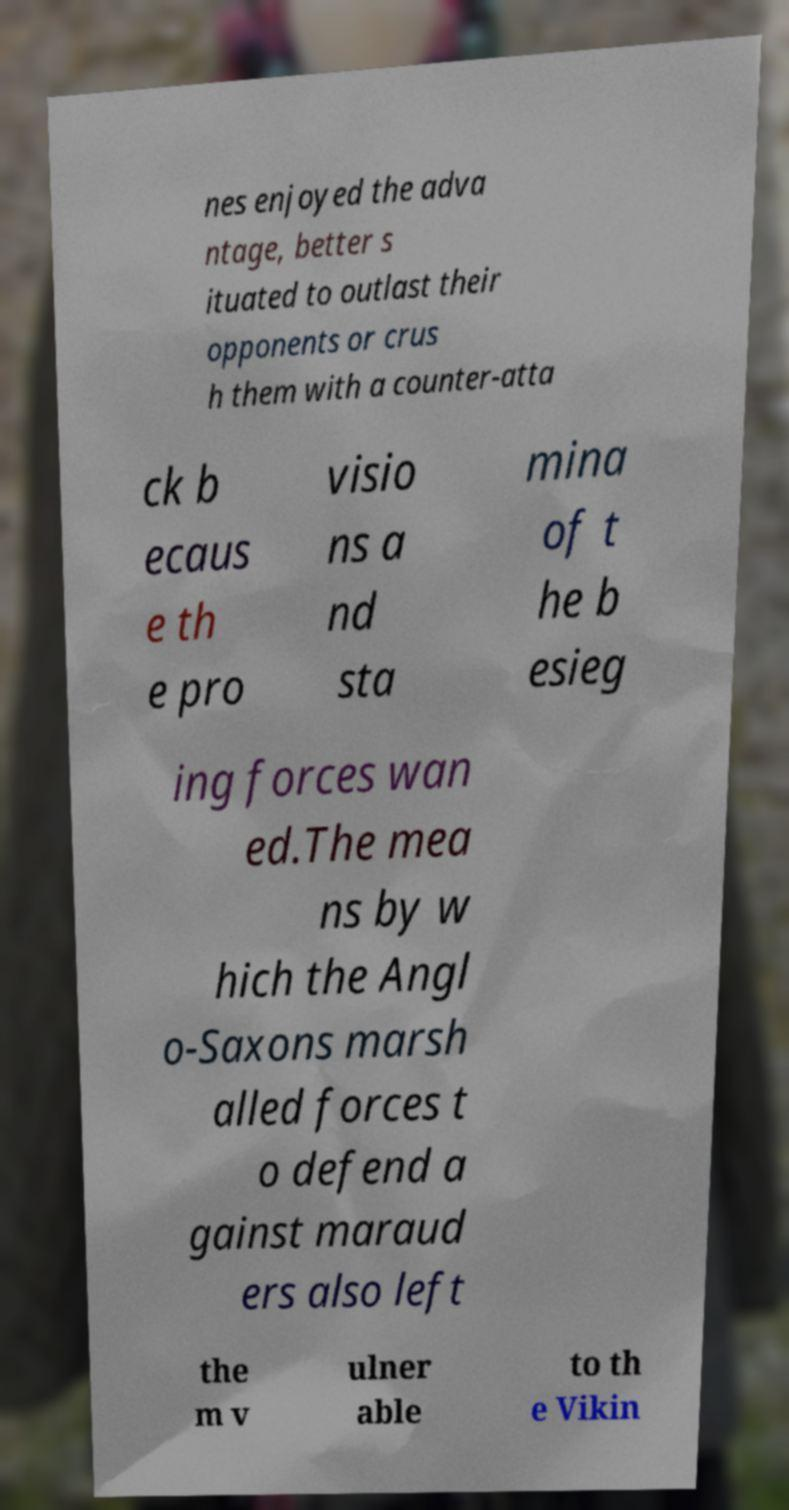Can you accurately transcribe the text from the provided image for me? nes enjoyed the adva ntage, better s ituated to outlast their opponents or crus h them with a counter-atta ck b ecaus e th e pro visio ns a nd sta mina of t he b esieg ing forces wan ed.The mea ns by w hich the Angl o-Saxons marsh alled forces t o defend a gainst maraud ers also left the m v ulner able to th e Vikin 